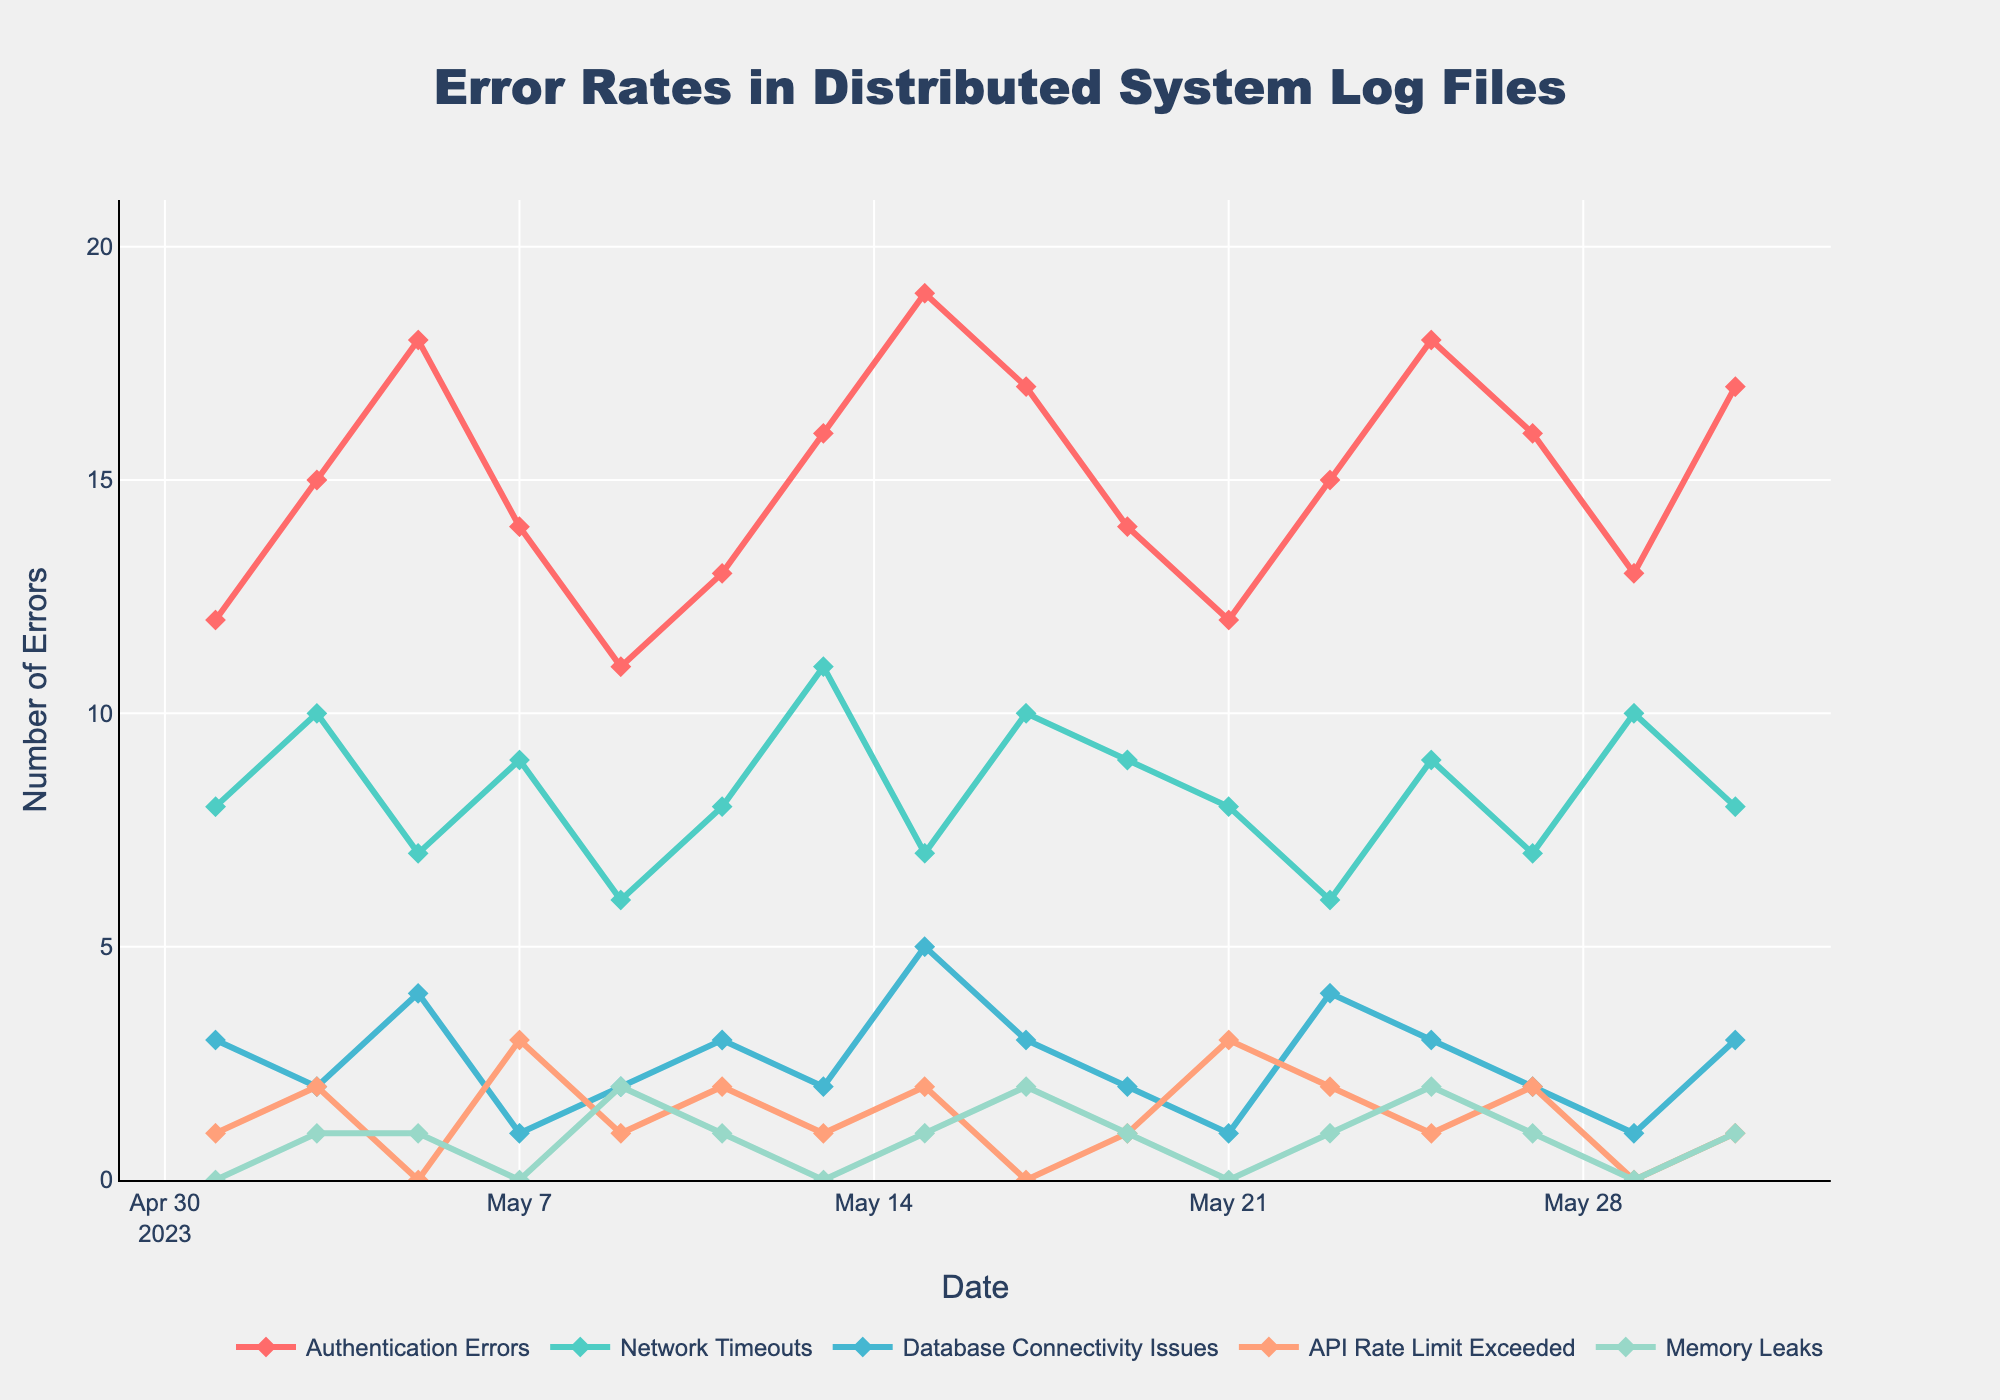which error type had the highest peak in May? The peak values for each error type are Authentication Errors (19), Network Timeouts (11), Database Connectivity Issues (5), API Rate Limit Exceeded (3), and Memory Leaks (2). The highest peak among these is 19 from Authentication Errors.
Answer: Authentication Errors On which date did Network Timeouts reach its maximum value? By examining the graph, the highest point for Network Timeouts is 11, which occurs on May 13.
Answer: May 13 What is the average number of API Rate Limit Exceeded errors throughout the month? Summing the API Rate Limit Exceeded errors: 1+2+0+3+1+2+1+2+0+1+3+2+1+2+1 = 22. There are 15 data points, so the average is 22/15 ≈ 1.47.
Answer: 1.47 How many days had more than 15 Authentication Errors? The days with over 15 Authentication Errors are May 05, May 13, May 15, May 17, and May 31. Thus, there are 5 such days.
Answer: 5 Which error type had no incidents reported on May 29? Reviewing the errors on May 29, the values are Authentication Errors (13), Network Timeouts (10), Database Connectivity Issues (1), API Rate Limit Exceeded (0), and Memory Leaks (0). Both API Rate Limit Exceeded and Memory Leaks had no incidents.
Answer: API Rate Limit Exceeded, Memory Leaks Among the errors types, which one shows the most consistency (least fluctuation) throughout May? By visually inspecting the lines on the chart, Memory Leaks remain almost at a constant low value, indicating the least fluctuation.
Answer: Memory Leaks What is the total number of Database Connectivity Issues for the month? Summing all the Database Connectivity Issues: 3+2+4+1+2+3+2+5+3+2+1+4+3+2+1 = 38
Answer: 38 How many times did Authentication Errors increase after a previous decrease? Authentication Errors increased after a decrease on May 03, May 11, May 13, and May 31. There are 4 such instances.
Answer: 4 Which error type had the lowest peak value and what was that value? By identifying the peak values: Memory Leaks (2) is the lowest among the error types.
Answer: Memory Leaks, 2 